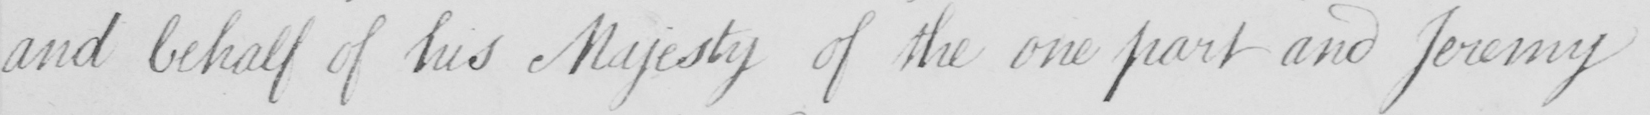Transcribe the text shown in this historical manuscript line. and behalf of his Majesty of the one part and Jeremy 